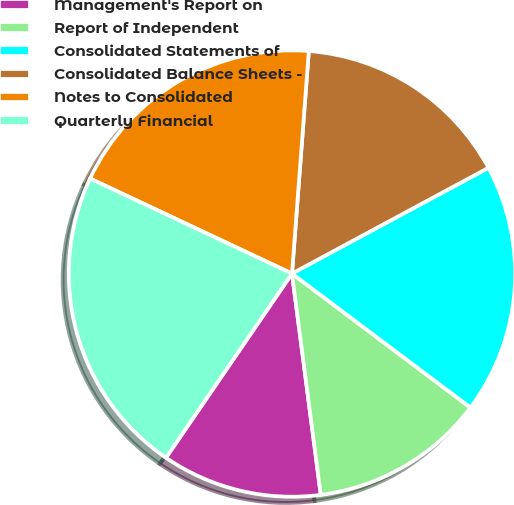Convert chart. <chart><loc_0><loc_0><loc_500><loc_500><pie_chart><fcel>Management's Report on<fcel>Report of Independent<fcel>Consolidated Statements of<fcel>Consolidated Balance Sheets -<fcel>Notes to Consolidated<fcel>Quarterly Financial<nl><fcel>11.61%<fcel>12.69%<fcel>18.11%<fcel>15.94%<fcel>19.2%<fcel>22.45%<nl></chart> 